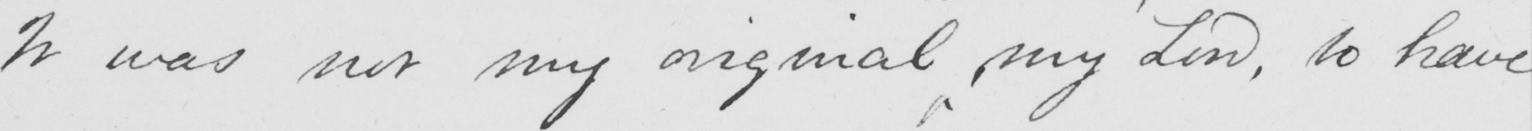Please provide the text content of this handwritten line. It was not my original  , my Lord , to have 